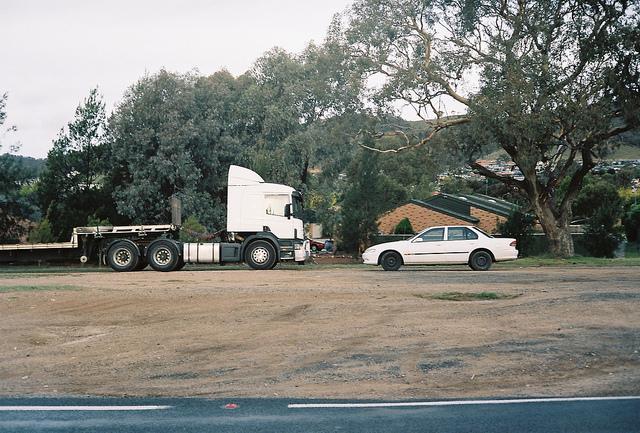Are these vehicles off:road?
Quick response, please. No. What color is the truck?
Keep it brief. White. What model is the car?
Concise answer only. Honda civic. What's in the background?
Answer briefly. Trees. How many wheels can be seen?
Keep it brief. 5. 